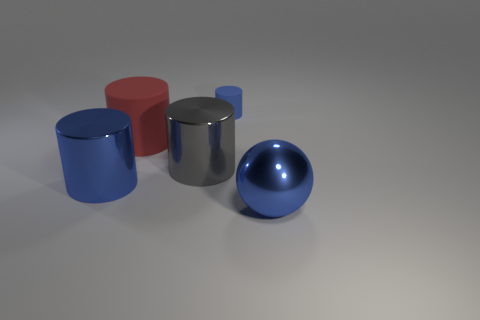Add 2 big blue metal objects. How many objects exist? 7 Subtract all cylinders. How many objects are left? 1 Subtract 0 cyan cylinders. How many objects are left? 5 Subtract all big purple things. Subtract all large shiny things. How many objects are left? 2 Add 5 large blue shiny things. How many large blue shiny things are left? 7 Add 4 red matte cylinders. How many red matte cylinders exist? 5 